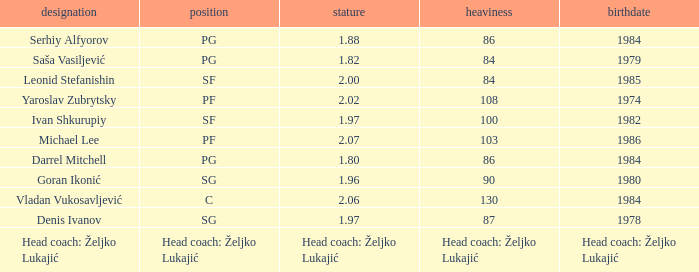What is the position of the player born in 1984 with a height of 1.80m? PG. Parse the table in full. {'header': ['designation', 'position', 'stature', 'heaviness', 'birthdate'], 'rows': [['Serhiy Alfyorov', 'PG', '1.88', '86', '1984'], ['Saša Vasiljević', 'PG', '1.82', '84', '1979'], ['Leonid Stefanishin', 'SF', '2.00', '84', '1985'], ['Yaroslav Zubrytsky', 'PF', '2.02', '108', '1974'], ['Ivan Shkurupiy', 'SF', '1.97', '100', '1982'], ['Michael Lee', 'PF', '2.07', '103', '1986'], ['Darrel Mitchell', 'PG', '1.80', '86', '1984'], ['Goran Ikonić', 'SG', '1.96', '90', '1980'], ['Vladan Vukosavljević', 'C', '2.06', '130', '1984'], ['Denis Ivanov', 'SG', '1.97', '87', '1978'], ['Head coach: Željko Lukajić', 'Head coach: Željko Lukajić', 'Head coach: Željko Lukajić', 'Head coach: Željko Lukajić', 'Head coach: Željko Lukajić']]} 